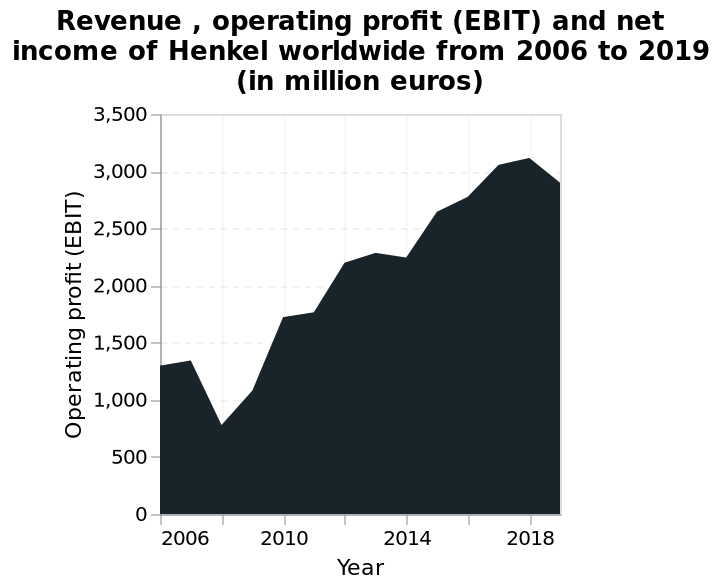<image>
please summary the statistics and relations of the chart The company had a decrease in operating profit in 2008. The company's profits have increased steadily from 2010 onwards. 